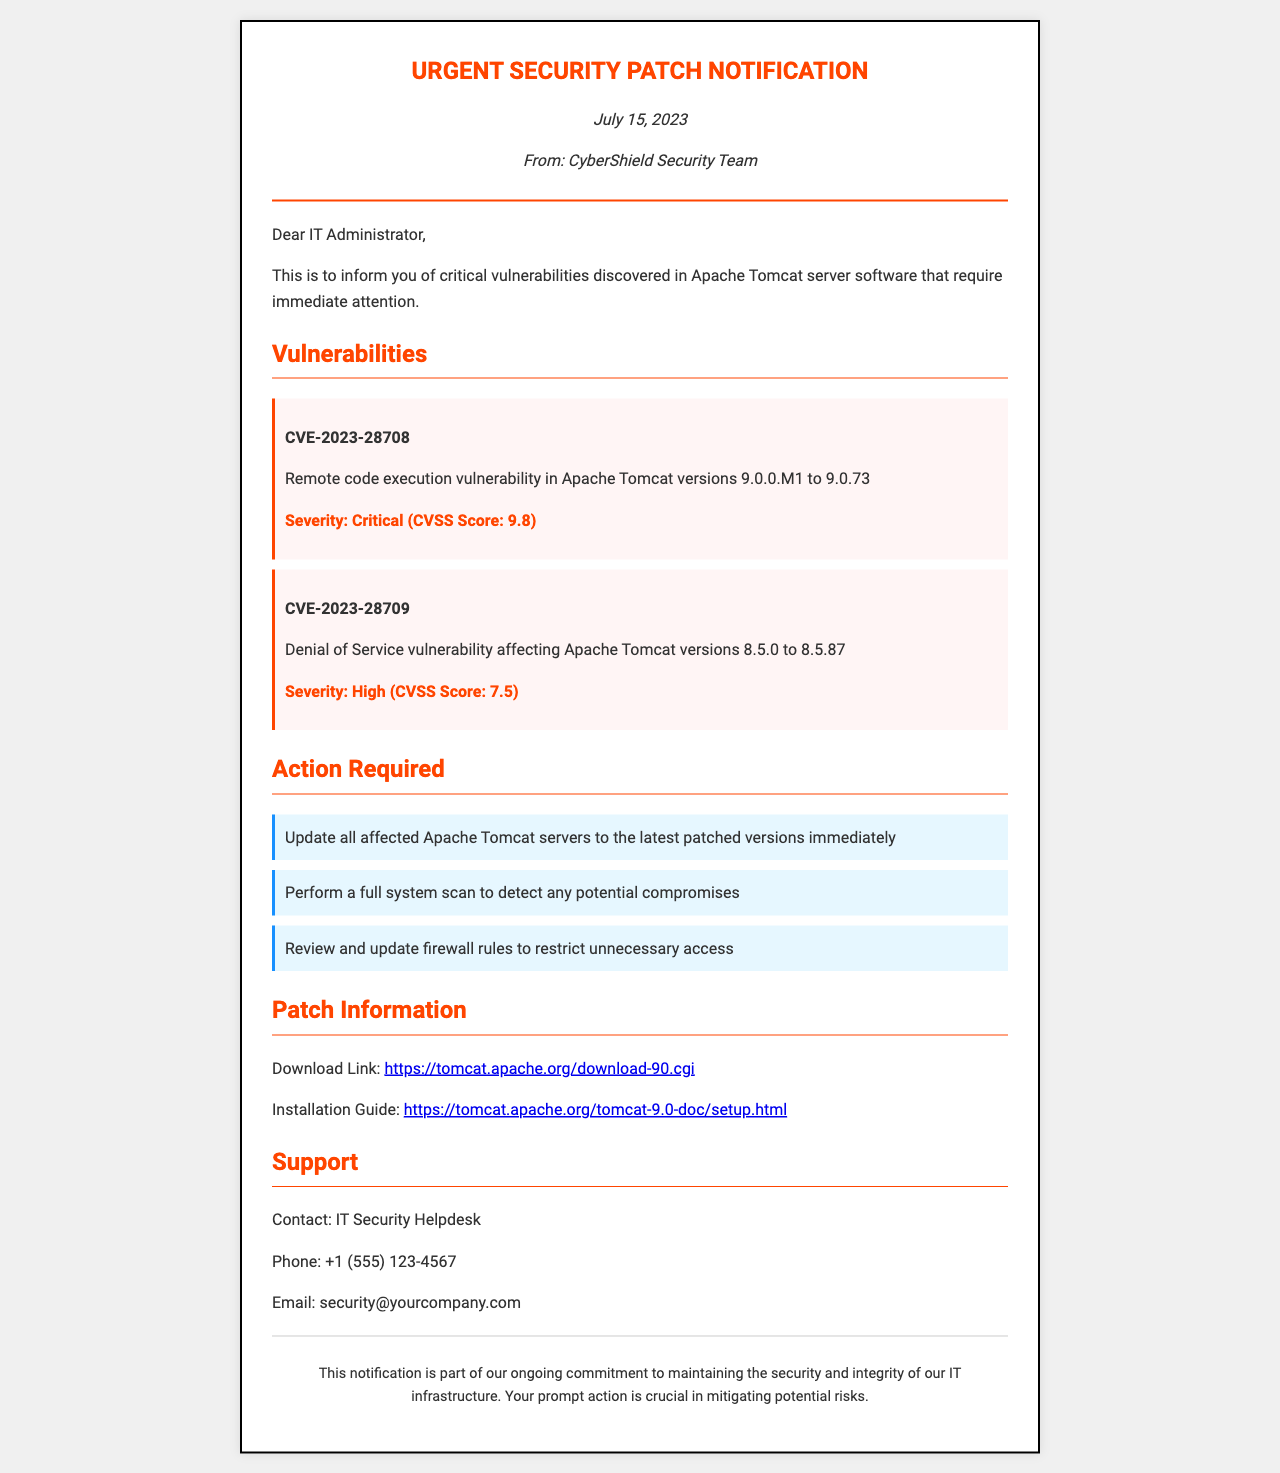What is the date of the notification? The date of the notification is explicitly stated at the beginning of the document.
Answer: July 15, 2023 Who issued the notification? The document mentions the issuer in the header section.
Answer: CyberShield Security Team What is the CVSS Score for CVE-2023-28708? The CVSS Score for CVE-2023-28708 is mentioned in the severity section related to this vulnerability.
Answer: 9.8 What action is required to protect against the vulnerabilities? The document lists several action items that need to be undertaken for security.
Answer: Update all affected Apache Tomcat servers to the latest patched versions immediately Which server software has critical vulnerabilities? The introduction section specifies which software has the vulnerabilities that require attention.
Answer: Apache Tomcat What is the support contact phone number? The contact information for support includes a phone number located at the end of the document.
Answer: +1 (555) 123-4567 How many vulnerabilities are listed in the document? The document provides the number of vulnerabilities discovered in the Apache Tomcat server software.
Answer: Two What is the severity of CVE-2023-28709? The severity of CVE-2023-28709 is listed in the description of that specific vulnerability.
Answer: High What is the action item related to firewall rules? One of the action items specifically addresses the firewall in the document.
Answer: Review and update firewall rules to restrict unnecessary access 